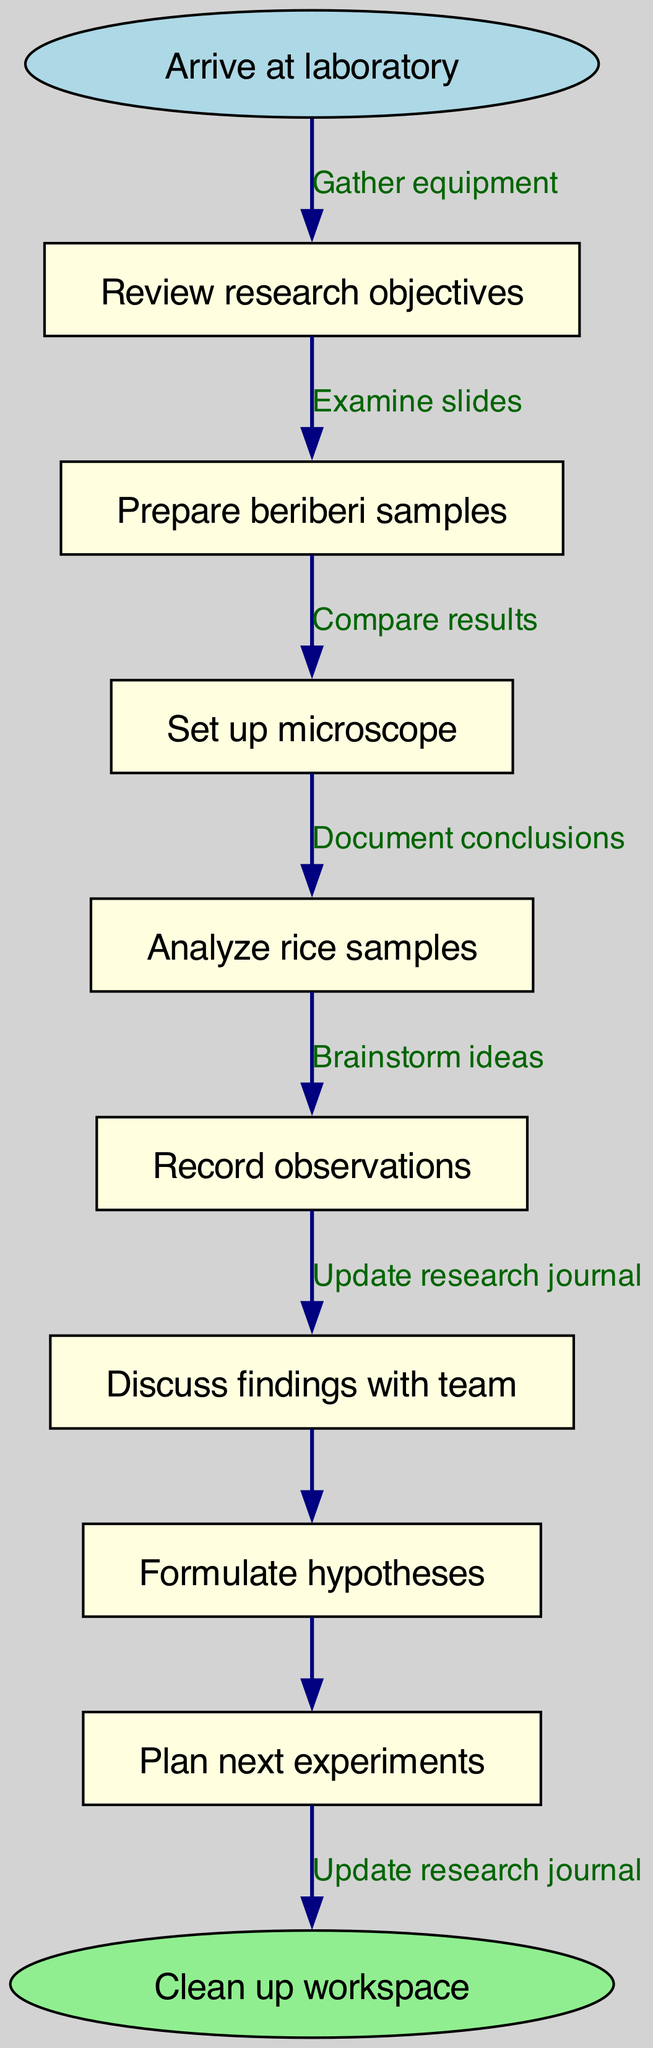What is the starting point of the workflow? The diagram indicates that the workflow begins with the node labeled "Arrive at laboratory."
Answer: Arrive at laboratory How many nodes are present in the diagram? By counting the individual labeled nodes, including the start and end nodes, we identify a total of 9 nodes in the diagram.
Answer: 9 What is the final step in the workflow? The last node before transitioning to the end node is "Plan next experiments," leading to the conclusion with "Clean up workspace."
Answer: Clean up workspace What is the first activity listed after arriving at the laboratory? The diagram shows that after arriving at the laboratory, the first node is "Review research objectives."
Answer: Review research objectives Which activity involves interacting with team members? The node "Discuss findings with team" explicitly indicates an interaction with team members as part of the workflow.
Answer: Discuss findings with team What edge connects the analysis of rice samples to recording observations? The edge labeled "Compare results" connects the "Analyze rice samples" node to the "Record observations" node.
Answer: Compare results Explain the progression from analyzing rice samples to formulating hypotheses. The workflow moves from "Analyze rice samples" to "Record observations" with the edge "Document conclusions," and directly transitions to "Formulate hypotheses." Therefore, the edge connecting to hypotheses is "Document conclusions."
Answer: Document conclusions What is the relationship between preparing beriberi samples and setting up the microscope? The edge from "Prepare beriberi samples" to "Set up microscope" indicates a sequential relationship, showing that preparing the samples is followed by the setup of the microscope.
Answer: Gather equipment How many edges are used in total to connect the nodes? The diagram displays 7 edges linking the nodes, including the connection to the final end node. Counting these shows that there are a total of 8 edges.
Answer: 8 